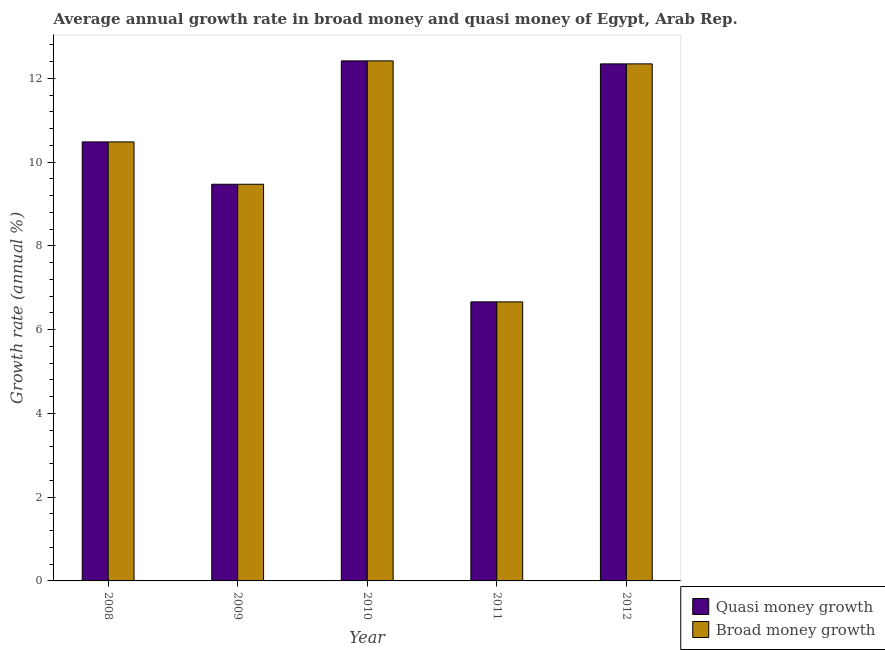How many different coloured bars are there?
Provide a short and direct response. 2. How many groups of bars are there?
Your answer should be very brief. 5. Are the number of bars on each tick of the X-axis equal?
Your answer should be compact. Yes. How many bars are there on the 4th tick from the left?
Your answer should be very brief. 2. What is the label of the 4th group of bars from the left?
Offer a terse response. 2011. In how many cases, is the number of bars for a given year not equal to the number of legend labels?
Make the answer very short. 0. What is the annual growth rate in broad money in 2010?
Your response must be concise. 12.42. Across all years, what is the maximum annual growth rate in quasi money?
Offer a terse response. 12.42. Across all years, what is the minimum annual growth rate in quasi money?
Your response must be concise. 6.66. In which year was the annual growth rate in broad money maximum?
Offer a very short reply. 2010. What is the total annual growth rate in broad money in the graph?
Offer a very short reply. 51.39. What is the difference between the annual growth rate in quasi money in 2009 and that in 2011?
Keep it short and to the point. 2.81. What is the difference between the annual growth rate in quasi money in 2012 and the annual growth rate in broad money in 2010?
Ensure brevity in your answer.  -0.07. What is the average annual growth rate in quasi money per year?
Keep it short and to the point. 10.28. In how many years, is the annual growth rate in quasi money greater than 2 %?
Your response must be concise. 5. What is the ratio of the annual growth rate in broad money in 2010 to that in 2011?
Make the answer very short. 1.86. Is the annual growth rate in broad money in 2008 less than that in 2011?
Provide a short and direct response. No. Is the difference between the annual growth rate in broad money in 2010 and 2011 greater than the difference between the annual growth rate in quasi money in 2010 and 2011?
Provide a succinct answer. No. What is the difference between the highest and the second highest annual growth rate in quasi money?
Give a very brief answer. 0.07. What is the difference between the highest and the lowest annual growth rate in broad money?
Your answer should be compact. 5.76. Is the sum of the annual growth rate in broad money in 2009 and 2011 greater than the maximum annual growth rate in quasi money across all years?
Your response must be concise. Yes. What does the 1st bar from the left in 2009 represents?
Keep it short and to the point. Quasi money growth. What does the 2nd bar from the right in 2012 represents?
Make the answer very short. Quasi money growth. How many bars are there?
Provide a short and direct response. 10. What is the difference between two consecutive major ticks on the Y-axis?
Make the answer very short. 2. Are the values on the major ticks of Y-axis written in scientific E-notation?
Offer a very short reply. No. Where does the legend appear in the graph?
Ensure brevity in your answer.  Bottom right. How many legend labels are there?
Offer a terse response. 2. What is the title of the graph?
Offer a terse response. Average annual growth rate in broad money and quasi money of Egypt, Arab Rep. Does "RDB concessional" appear as one of the legend labels in the graph?
Provide a succinct answer. No. What is the label or title of the X-axis?
Ensure brevity in your answer.  Year. What is the label or title of the Y-axis?
Provide a succinct answer. Growth rate (annual %). What is the Growth rate (annual %) of Quasi money growth in 2008?
Your answer should be compact. 10.49. What is the Growth rate (annual %) of Broad money growth in 2008?
Make the answer very short. 10.49. What is the Growth rate (annual %) of Quasi money growth in 2009?
Give a very brief answer. 9.47. What is the Growth rate (annual %) of Broad money growth in 2009?
Provide a succinct answer. 9.47. What is the Growth rate (annual %) of Quasi money growth in 2010?
Keep it short and to the point. 12.42. What is the Growth rate (annual %) of Broad money growth in 2010?
Your answer should be very brief. 12.42. What is the Growth rate (annual %) in Quasi money growth in 2011?
Provide a succinct answer. 6.66. What is the Growth rate (annual %) of Broad money growth in 2011?
Offer a very short reply. 6.66. What is the Growth rate (annual %) of Quasi money growth in 2012?
Your answer should be very brief. 12.35. What is the Growth rate (annual %) in Broad money growth in 2012?
Offer a terse response. 12.35. Across all years, what is the maximum Growth rate (annual %) of Quasi money growth?
Offer a very short reply. 12.42. Across all years, what is the maximum Growth rate (annual %) of Broad money growth?
Provide a succinct answer. 12.42. Across all years, what is the minimum Growth rate (annual %) of Quasi money growth?
Make the answer very short. 6.66. Across all years, what is the minimum Growth rate (annual %) in Broad money growth?
Your answer should be compact. 6.66. What is the total Growth rate (annual %) in Quasi money growth in the graph?
Ensure brevity in your answer.  51.39. What is the total Growth rate (annual %) in Broad money growth in the graph?
Offer a very short reply. 51.39. What is the difference between the Growth rate (annual %) of Quasi money growth in 2008 and that in 2009?
Make the answer very short. 1.01. What is the difference between the Growth rate (annual %) of Broad money growth in 2008 and that in 2009?
Make the answer very short. 1.01. What is the difference between the Growth rate (annual %) in Quasi money growth in 2008 and that in 2010?
Your answer should be very brief. -1.94. What is the difference between the Growth rate (annual %) in Broad money growth in 2008 and that in 2010?
Give a very brief answer. -1.94. What is the difference between the Growth rate (annual %) of Quasi money growth in 2008 and that in 2011?
Ensure brevity in your answer.  3.82. What is the difference between the Growth rate (annual %) of Broad money growth in 2008 and that in 2011?
Offer a terse response. 3.82. What is the difference between the Growth rate (annual %) in Quasi money growth in 2008 and that in 2012?
Offer a very short reply. -1.86. What is the difference between the Growth rate (annual %) of Broad money growth in 2008 and that in 2012?
Offer a terse response. -1.86. What is the difference between the Growth rate (annual %) in Quasi money growth in 2009 and that in 2010?
Offer a very short reply. -2.95. What is the difference between the Growth rate (annual %) in Broad money growth in 2009 and that in 2010?
Keep it short and to the point. -2.95. What is the difference between the Growth rate (annual %) of Quasi money growth in 2009 and that in 2011?
Ensure brevity in your answer.  2.81. What is the difference between the Growth rate (annual %) of Broad money growth in 2009 and that in 2011?
Keep it short and to the point. 2.81. What is the difference between the Growth rate (annual %) of Quasi money growth in 2009 and that in 2012?
Provide a short and direct response. -2.87. What is the difference between the Growth rate (annual %) in Broad money growth in 2009 and that in 2012?
Your response must be concise. -2.87. What is the difference between the Growth rate (annual %) of Quasi money growth in 2010 and that in 2011?
Your answer should be compact. 5.76. What is the difference between the Growth rate (annual %) of Broad money growth in 2010 and that in 2011?
Your answer should be very brief. 5.76. What is the difference between the Growth rate (annual %) of Quasi money growth in 2010 and that in 2012?
Make the answer very short. 0.07. What is the difference between the Growth rate (annual %) in Broad money growth in 2010 and that in 2012?
Provide a short and direct response. 0.07. What is the difference between the Growth rate (annual %) of Quasi money growth in 2011 and that in 2012?
Ensure brevity in your answer.  -5.68. What is the difference between the Growth rate (annual %) in Broad money growth in 2011 and that in 2012?
Provide a succinct answer. -5.68. What is the difference between the Growth rate (annual %) in Quasi money growth in 2008 and the Growth rate (annual %) in Broad money growth in 2009?
Provide a short and direct response. 1.01. What is the difference between the Growth rate (annual %) of Quasi money growth in 2008 and the Growth rate (annual %) of Broad money growth in 2010?
Ensure brevity in your answer.  -1.94. What is the difference between the Growth rate (annual %) of Quasi money growth in 2008 and the Growth rate (annual %) of Broad money growth in 2011?
Your answer should be compact. 3.82. What is the difference between the Growth rate (annual %) in Quasi money growth in 2008 and the Growth rate (annual %) in Broad money growth in 2012?
Your answer should be very brief. -1.86. What is the difference between the Growth rate (annual %) of Quasi money growth in 2009 and the Growth rate (annual %) of Broad money growth in 2010?
Offer a terse response. -2.95. What is the difference between the Growth rate (annual %) in Quasi money growth in 2009 and the Growth rate (annual %) in Broad money growth in 2011?
Your response must be concise. 2.81. What is the difference between the Growth rate (annual %) of Quasi money growth in 2009 and the Growth rate (annual %) of Broad money growth in 2012?
Provide a short and direct response. -2.87. What is the difference between the Growth rate (annual %) in Quasi money growth in 2010 and the Growth rate (annual %) in Broad money growth in 2011?
Offer a terse response. 5.76. What is the difference between the Growth rate (annual %) in Quasi money growth in 2010 and the Growth rate (annual %) in Broad money growth in 2012?
Provide a succinct answer. 0.07. What is the difference between the Growth rate (annual %) in Quasi money growth in 2011 and the Growth rate (annual %) in Broad money growth in 2012?
Offer a very short reply. -5.68. What is the average Growth rate (annual %) of Quasi money growth per year?
Give a very brief answer. 10.28. What is the average Growth rate (annual %) in Broad money growth per year?
Your answer should be compact. 10.28. In the year 2012, what is the difference between the Growth rate (annual %) in Quasi money growth and Growth rate (annual %) in Broad money growth?
Offer a very short reply. 0. What is the ratio of the Growth rate (annual %) in Quasi money growth in 2008 to that in 2009?
Provide a succinct answer. 1.11. What is the ratio of the Growth rate (annual %) in Broad money growth in 2008 to that in 2009?
Offer a very short reply. 1.11. What is the ratio of the Growth rate (annual %) in Quasi money growth in 2008 to that in 2010?
Your answer should be compact. 0.84. What is the ratio of the Growth rate (annual %) in Broad money growth in 2008 to that in 2010?
Offer a terse response. 0.84. What is the ratio of the Growth rate (annual %) of Quasi money growth in 2008 to that in 2011?
Your answer should be compact. 1.57. What is the ratio of the Growth rate (annual %) in Broad money growth in 2008 to that in 2011?
Make the answer very short. 1.57. What is the ratio of the Growth rate (annual %) in Quasi money growth in 2008 to that in 2012?
Make the answer very short. 0.85. What is the ratio of the Growth rate (annual %) in Broad money growth in 2008 to that in 2012?
Keep it short and to the point. 0.85. What is the ratio of the Growth rate (annual %) of Quasi money growth in 2009 to that in 2010?
Offer a very short reply. 0.76. What is the ratio of the Growth rate (annual %) in Broad money growth in 2009 to that in 2010?
Provide a succinct answer. 0.76. What is the ratio of the Growth rate (annual %) in Quasi money growth in 2009 to that in 2011?
Make the answer very short. 1.42. What is the ratio of the Growth rate (annual %) in Broad money growth in 2009 to that in 2011?
Provide a short and direct response. 1.42. What is the ratio of the Growth rate (annual %) in Quasi money growth in 2009 to that in 2012?
Offer a very short reply. 0.77. What is the ratio of the Growth rate (annual %) in Broad money growth in 2009 to that in 2012?
Your response must be concise. 0.77. What is the ratio of the Growth rate (annual %) in Quasi money growth in 2010 to that in 2011?
Your response must be concise. 1.86. What is the ratio of the Growth rate (annual %) in Broad money growth in 2010 to that in 2011?
Ensure brevity in your answer.  1.86. What is the ratio of the Growth rate (annual %) in Quasi money growth in 2011 to that in 2012?
Keep it short and to the point. 0.54. What is the ratio of the Growth rate (annual %) of Broad money growth in 2011 to that in 2012?
Offer a terse response. 0.54. What is the difference between the highest and the second highest Growth rate (annual %) of Quasi money growth?
Your answer should be very brief. 0.07. What is the difference between the highest and the second highest Growth rate (annual %) in Broad money growth?
Make the answer very short. 0.07. What is the difference between the highest and the lowest Growth rate (annual %) of Quasi money growth?
Make the answer very short. 5.76. What is the difference between the highest and the lowest Growth rate (annual %) in Broad money growth?
Your answer should be compact. 5.76. 